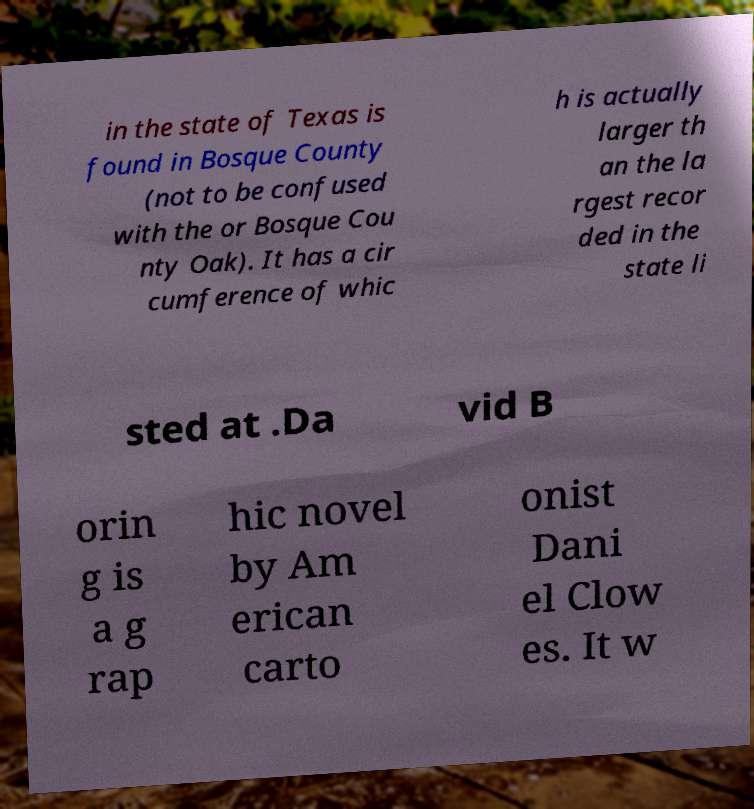Can you read and provide the text displayed in the image?This photo seems to have some interesting text. Can you extract and type it out for me? in the state of Texas is found in Bosque County (not to be confused with the or Bosque Cou nty Oak). It has a cir cumference of whic h is actually larger th an the la rgest recor ded in the state li sted at .Da vid B orin g is a g rap hic novel by Am erican carto onist Dani el Clow es. It w 